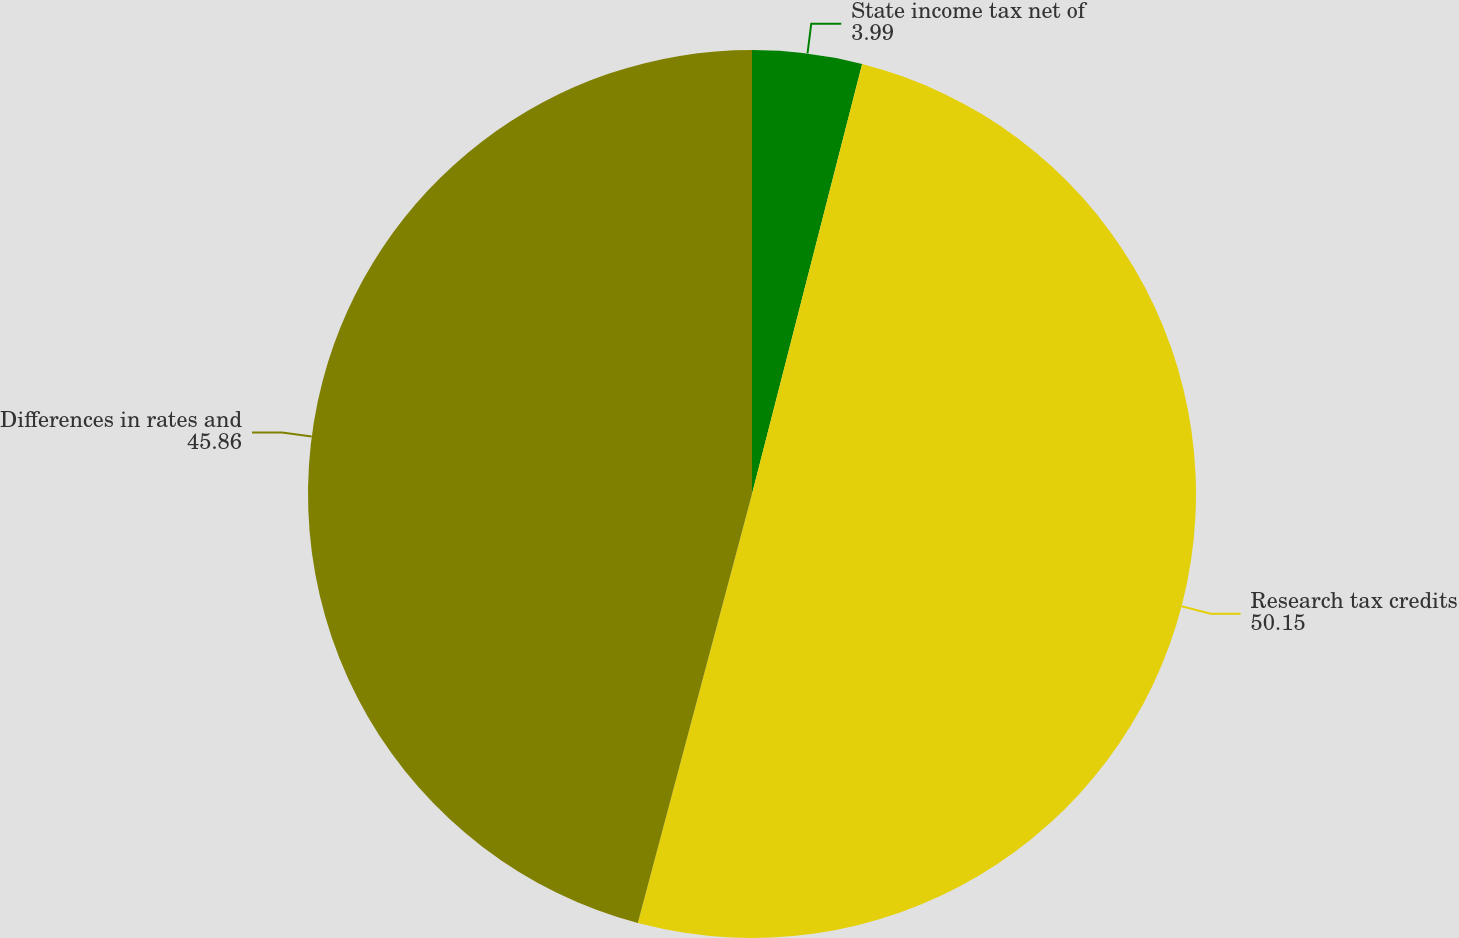<chart> <loc_0><loc_0><loc_500><loc_500><pie_chart><fcel>State income tax net of<fcel>Research tax credits<fcel>Differences in rates and<nl><fcel>3.99%<fcel>50.15%<fcel>45.86%<nl></chart> 